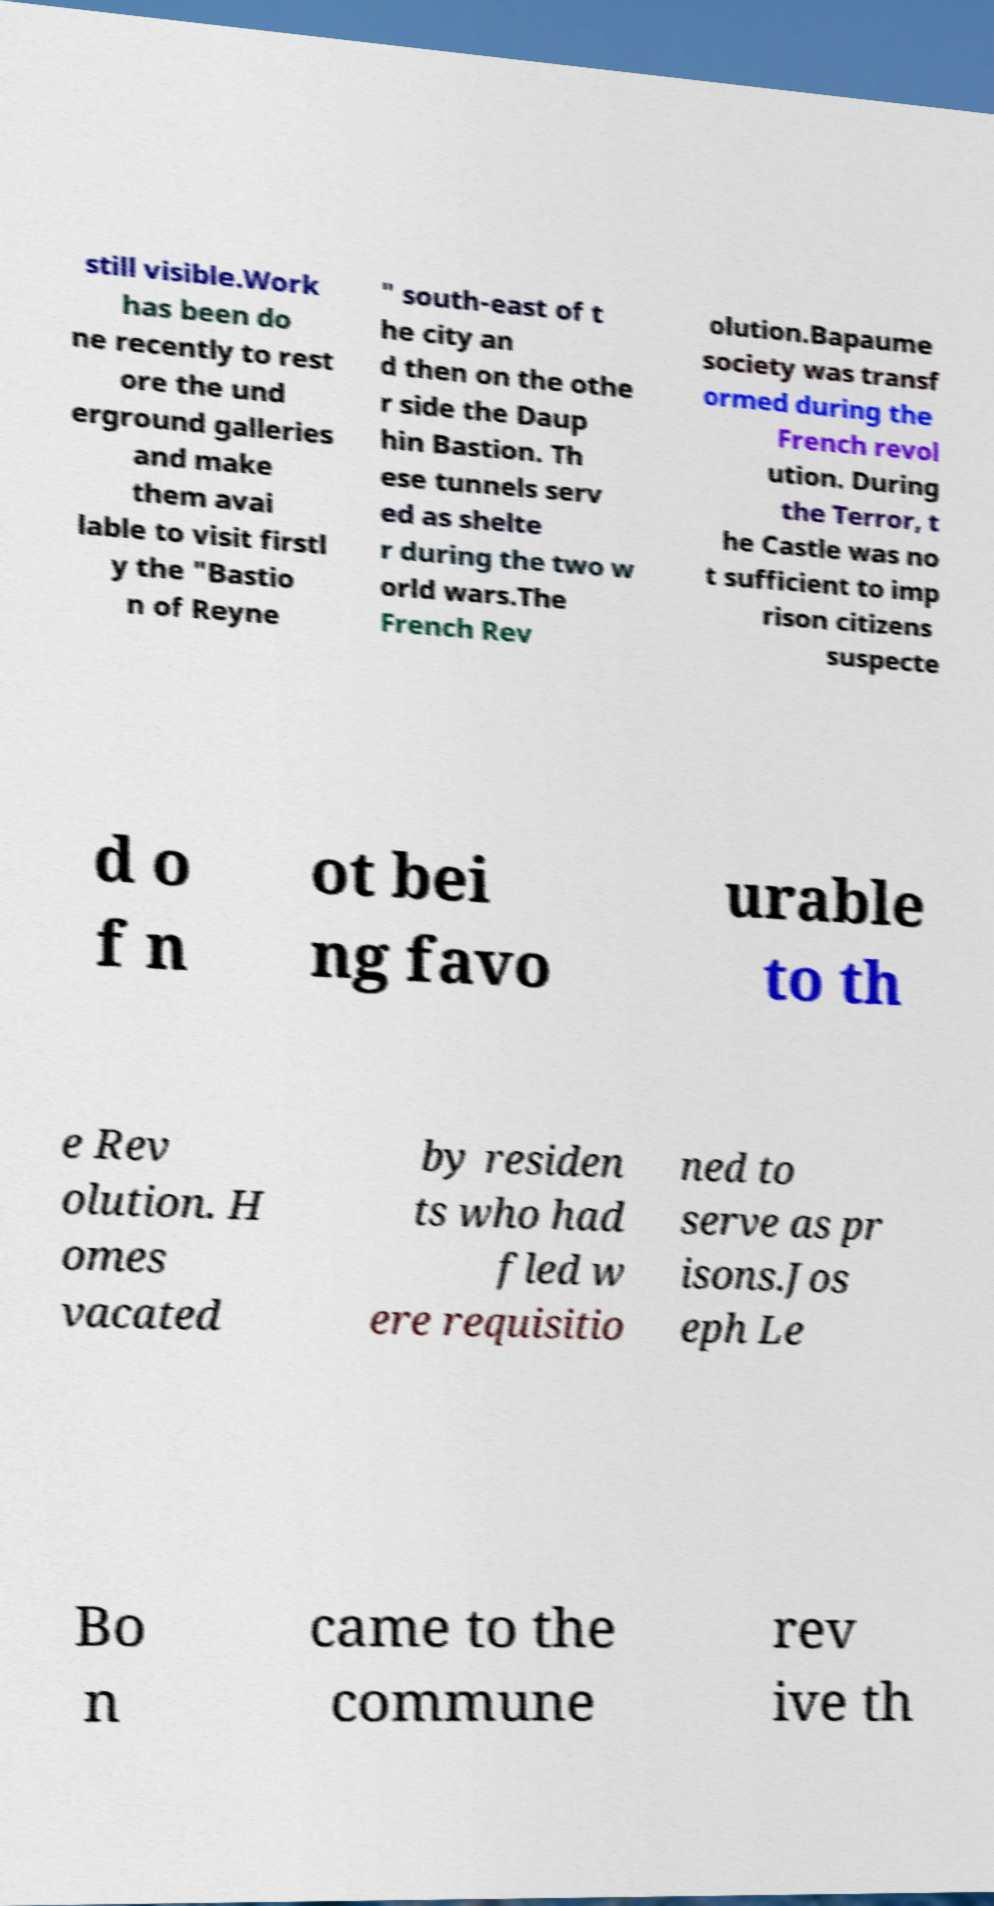Could you extract and type out the text from this image? still visible.Work has been do ne recently to rest ore the und erground galleries and make them avai lable to visit firstl y the "Bastio n of Reyne " south-east of t he city an d then on the othe r side the Daup hin Bastion. Th ese tunnels serv ed as shelte r during the two w orld wars.The French Rev olution.Bapaume society was transf ormed during the French revol ution. During the Terror, t he Castle was no t sufficient to imp rison citizens suspecte d o f n ot bei ng favo urable to th e Rev olution. H omes vacated by residen ts who had fled w ere requisitio ned to serve as pr isons.Jos eph Le Bo n came to the commune rev ive th 